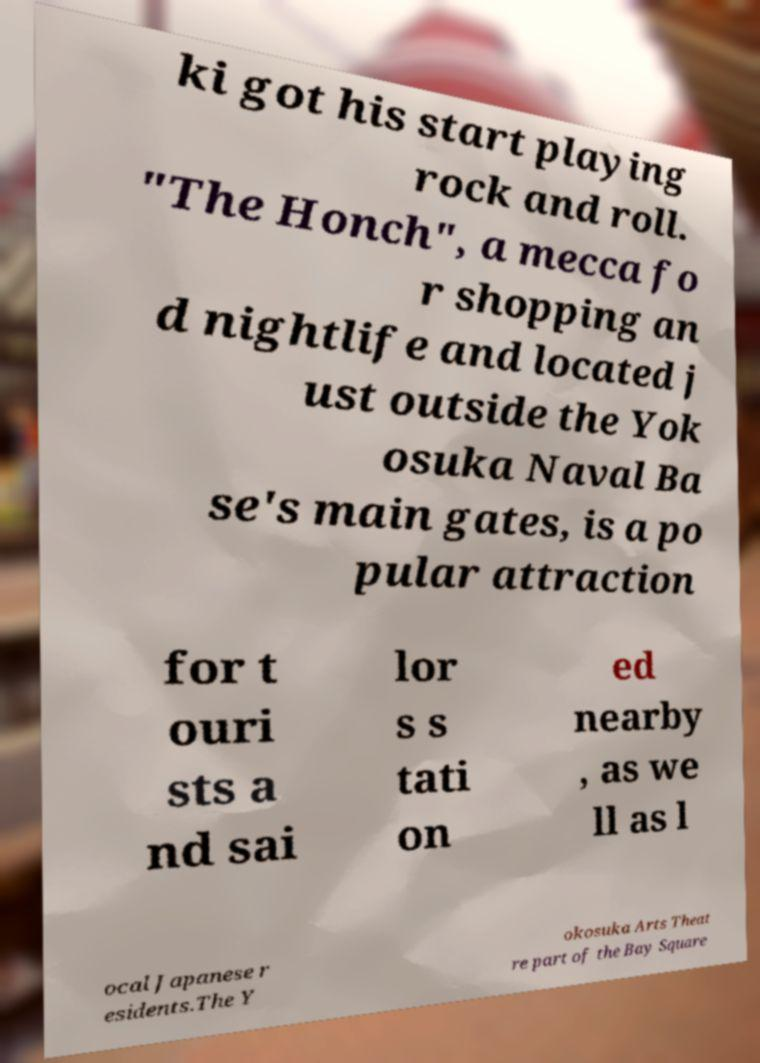Please read and relay the text visible in this image. What does it say? ki got his start playing rock and roll. "The Honch", a mecca fo r shopping an d nightlife and located j ust outside the Yok osuka Naval Ba se's main gates, is a po pular attraction for t ouri sts a nd sai lor s s tati on ed nearby , as we ll as l ocal Japanese r esidents.The Y okosuka Arts Theat re part of the Bay Square 